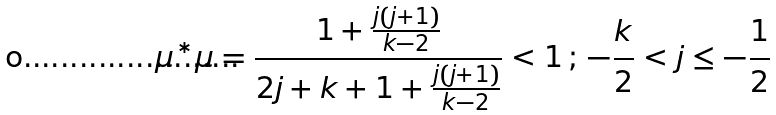<formula> <loc_0><loc_0><loc_500><loc_500>\mu ^ { * } \mu = \frac { 1 + \frac { j ( j + 1 ) } { k - 2 } } { 2 j + k + 1 + \frac { j ( j + 1 ) } { k - 2 } } < 1 \, ; \, - \frac { k } { 2 } < j \leq - \frac { 1 } { 2 }</formula> 